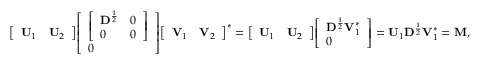<formula> <loc_0><loc_0><loc_500><loc_500>{ \left [ \begin{array} { l l } { U _ { 1 } } & { U _ { 2 } } \end{array} \right ] } { \left [ \begin{array} { l } { { \left [ \begin{array} { l l } { \mathbf D ^ { \frac { 1 } { 2 } } } & { 0 } \\ { 0 } & { 0 } \end{array} \right ] } } \\ { 0 } \end{array} \right ] } { \left [ \begin{array} { l l } { V _ { 1 } } & { V _ { 2 } } \end{array} \right ] } ^ { * } = { \left [ \begin{array} { l l } { U _ { 1 } } & { U _ { 2 } } \end{array} \right ] } { \left [ \begin{array} { l } { D ^ { \frac { 1 } { 2 } } V _ { 1 } ^ { * } } \\ { 0 } \end{array} \right ] } = U _ { 1 } D ^ { \frac { 1 } { 2 } } V _ { 1 } ^ { * } = M ,</formula> 